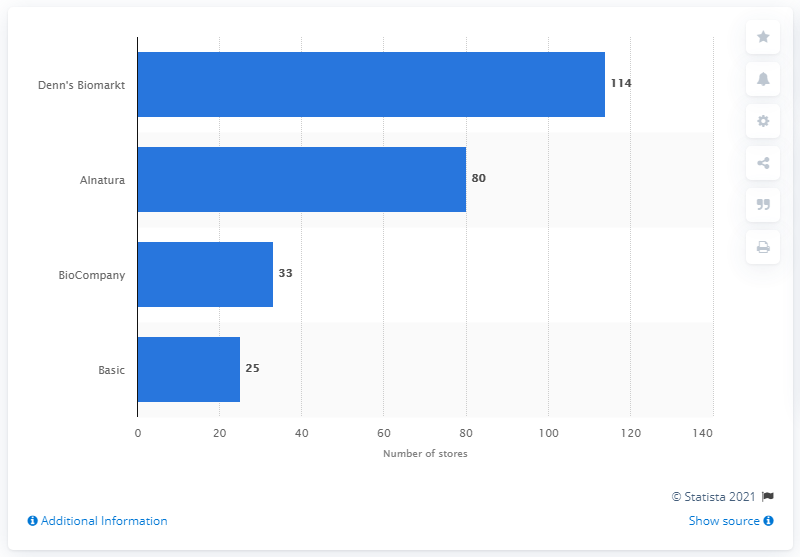Mention a couple of crucial points in this snapshot. Denn's Biomarkt had 114 stores in Germany in November 2014. 